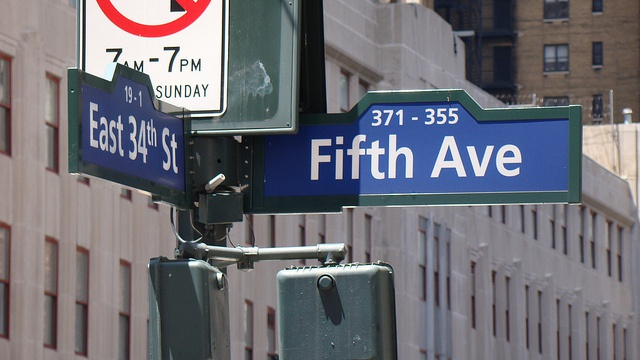Describe the objects in this image and their specific colors. I can see a traffic light in gray, purple, black, and white tones in this image. 